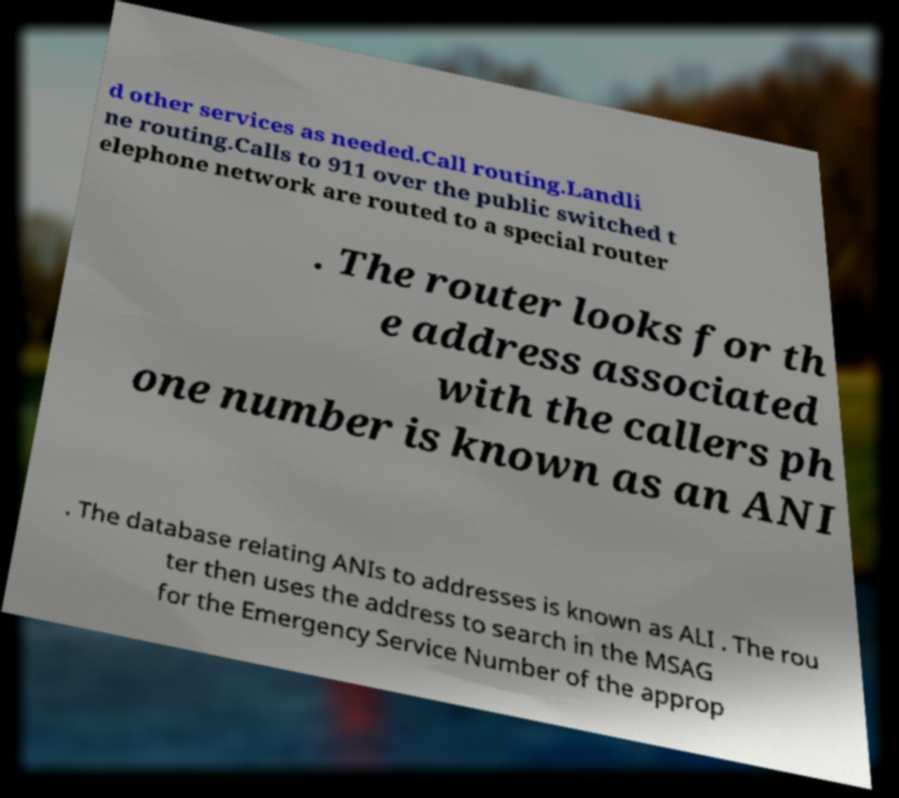I need the written content from this picture converted into text. Can you do that? d other services as needed.Call routing.Landli ne routing.Calls to 911 over the public switched t elephone network are routed to a special router . The router looks for th e address associated with the callers ph one number is known as an ANI . The database relating ANIs to addresses is known as ALI . The rou ter then uses the address to search in the MSAG for the Emergency Service Number of the approp 